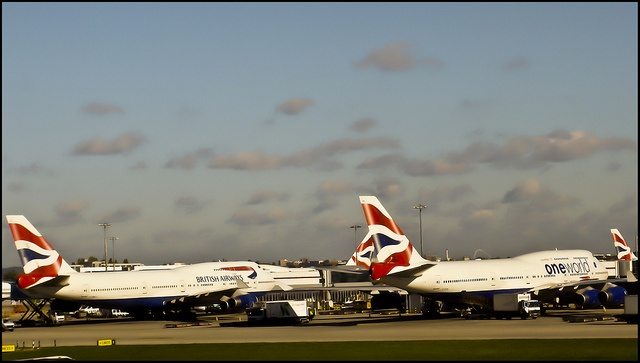Describe the objects in this image and their specific colors. I can see airplane in black, beige, tan, and maroon tones, airplane in black, beige, tan, and maroon tones, truck in black, beige, and olive tones, truck in black and ivory tones, and airplane in black, beige, tan, and maroon tones in this image. 